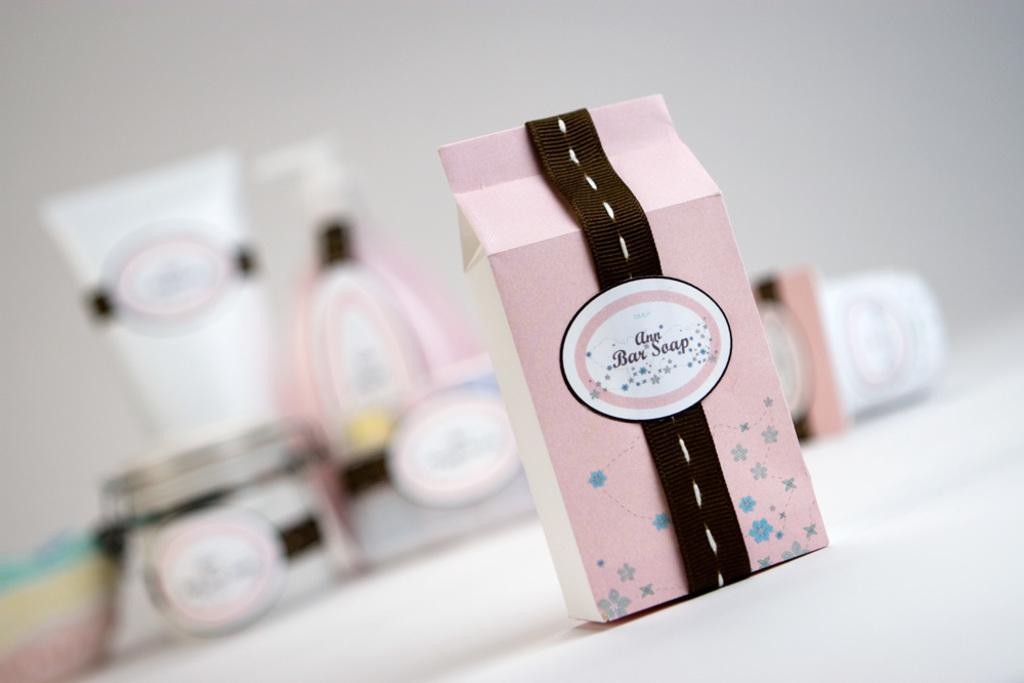What is the main object on the platform in the image? There is a box on a platform in the image. What is the color of the background in the image? The background in the image is white. How many boxes can be seen in the image? There are boxes visible in the image. What is the long, cylindrical object in the image? There is a tube in the image. What type of containers are present in the image? There are bottles in the image. What type of blood vessels can be seen in the image? There are no blood vessels or blood present in the image. Where is the meeting taking place in the image? There is no meeting or any indication of a gathering in the image. 